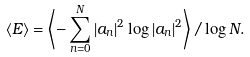<formula> <loc_0><loc_0><loc_500><loc_500>\left \langle E \right \rangle = \left \langle - \sum _ { n = 0 } ^ { N } | a _ { n } | ^ { 2 } \log | a _ { n } | ^ { 2 } \right \rangle / \log N .</formula> 